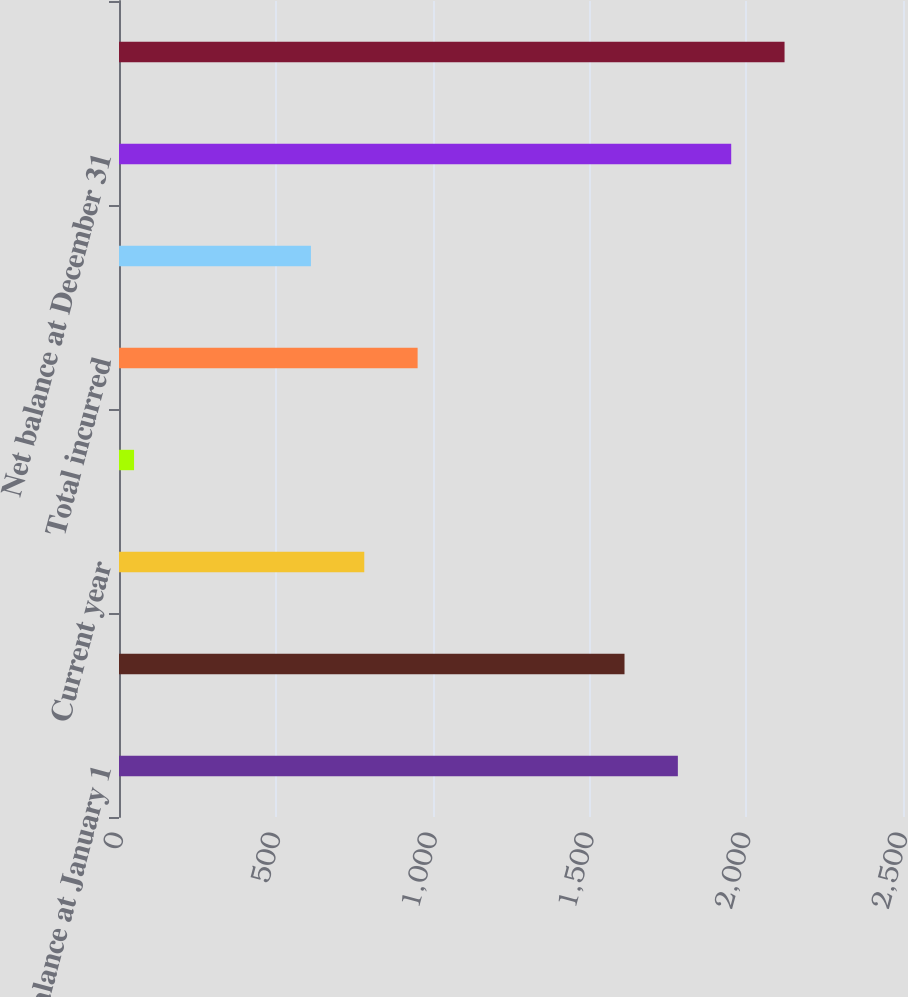<chart> <loc_0><loc_0><loc_500><loc_500><bar_chart><fcel>Balance at January 1<fcel>Net balance at January 1<fcel>Current year<fcel>Prior years<fcel>Total incurred<fcel>Total paid<fcel>Net balance at December 31<fcel>Balance at December 31<nl><fcel>1782.1<fcel>1612<fcel>782.1<fcel>48<fcel>952.2<fcel>612<fcel>1952.2<fcel>2122.3<nl></chart> 